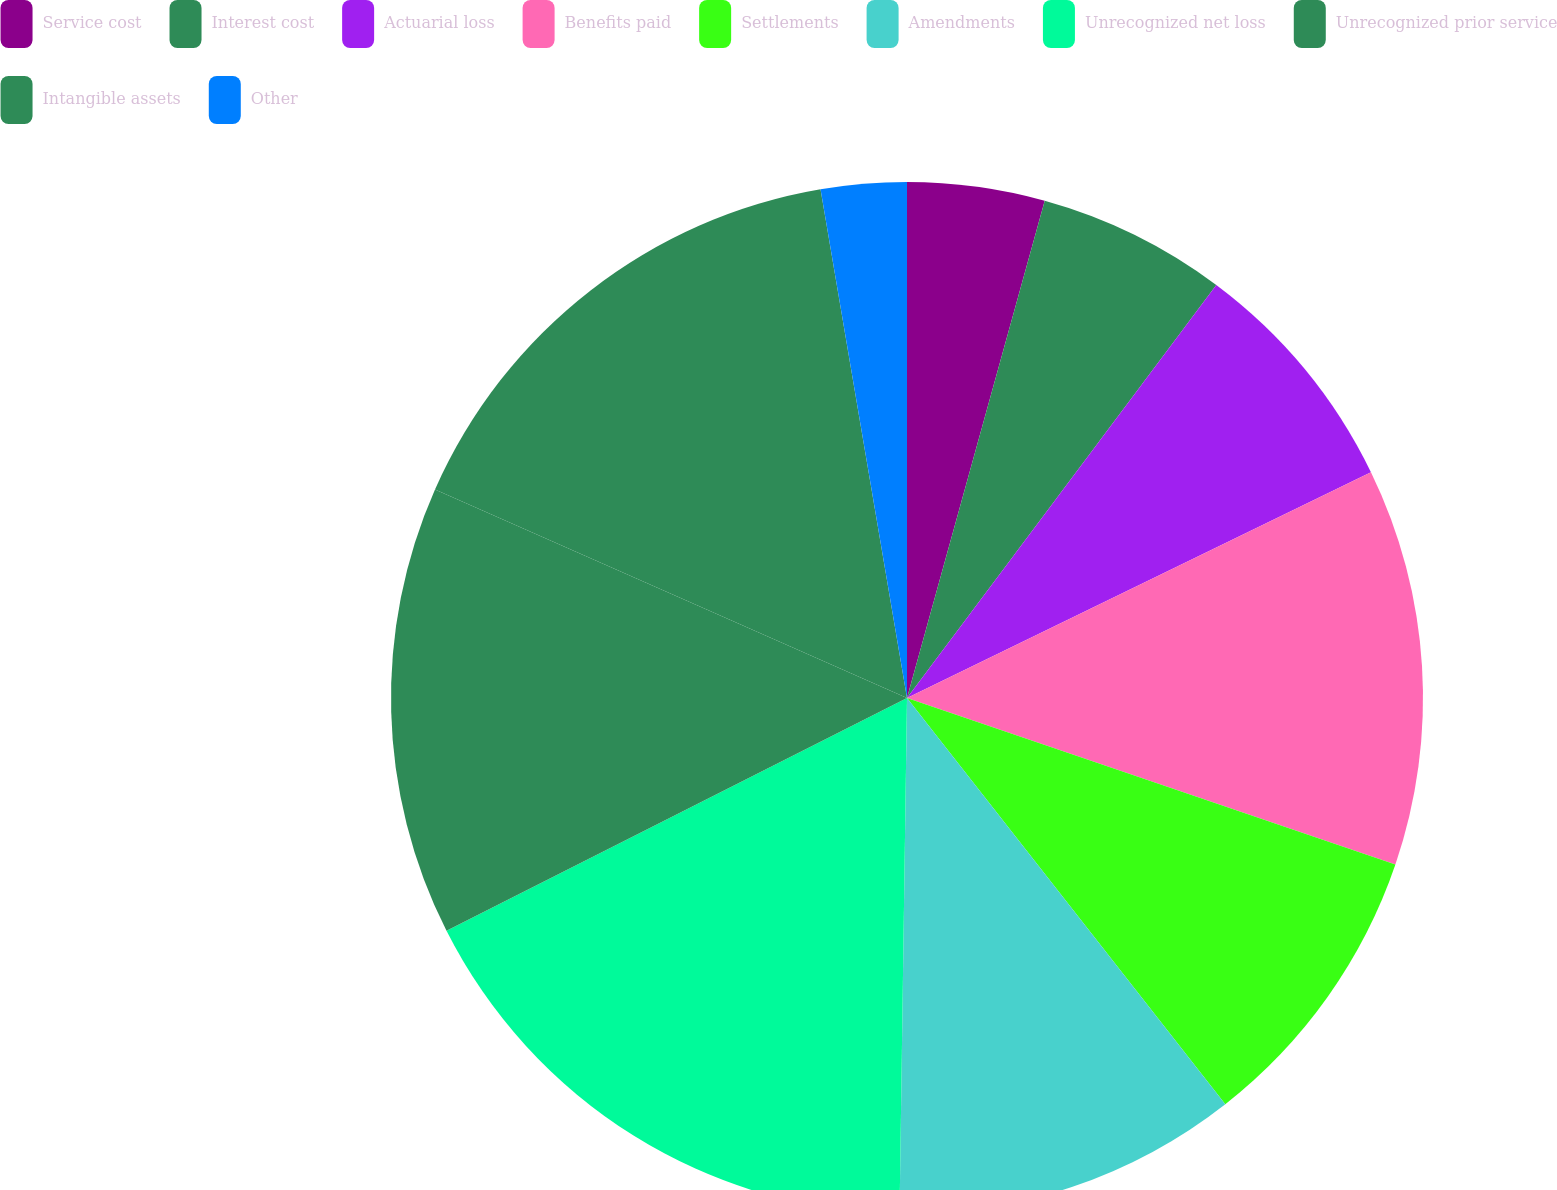<chart> <loc_0><loc_0><loc_500><loc_500><pie_chart><fcel>Service cost<fcel>Interest cost<fcel>Actuarial loss<fcel>Benefits paid<fcel>Settlements<fcel>Amendments<fcel>Unrecognized net loss<fcel>Unrecognized prior service<fcel>Intangible assets<fcel>Other<nl><fcel>4.3%<fcel>5.93%<fcel>7.56%<fcel>12.44%<fcel>9.19%<fcel>10.81%<fcel>17.32%<fcel>14.07%<fcel>15.7%<fcel>2.68%<nl></chart> 